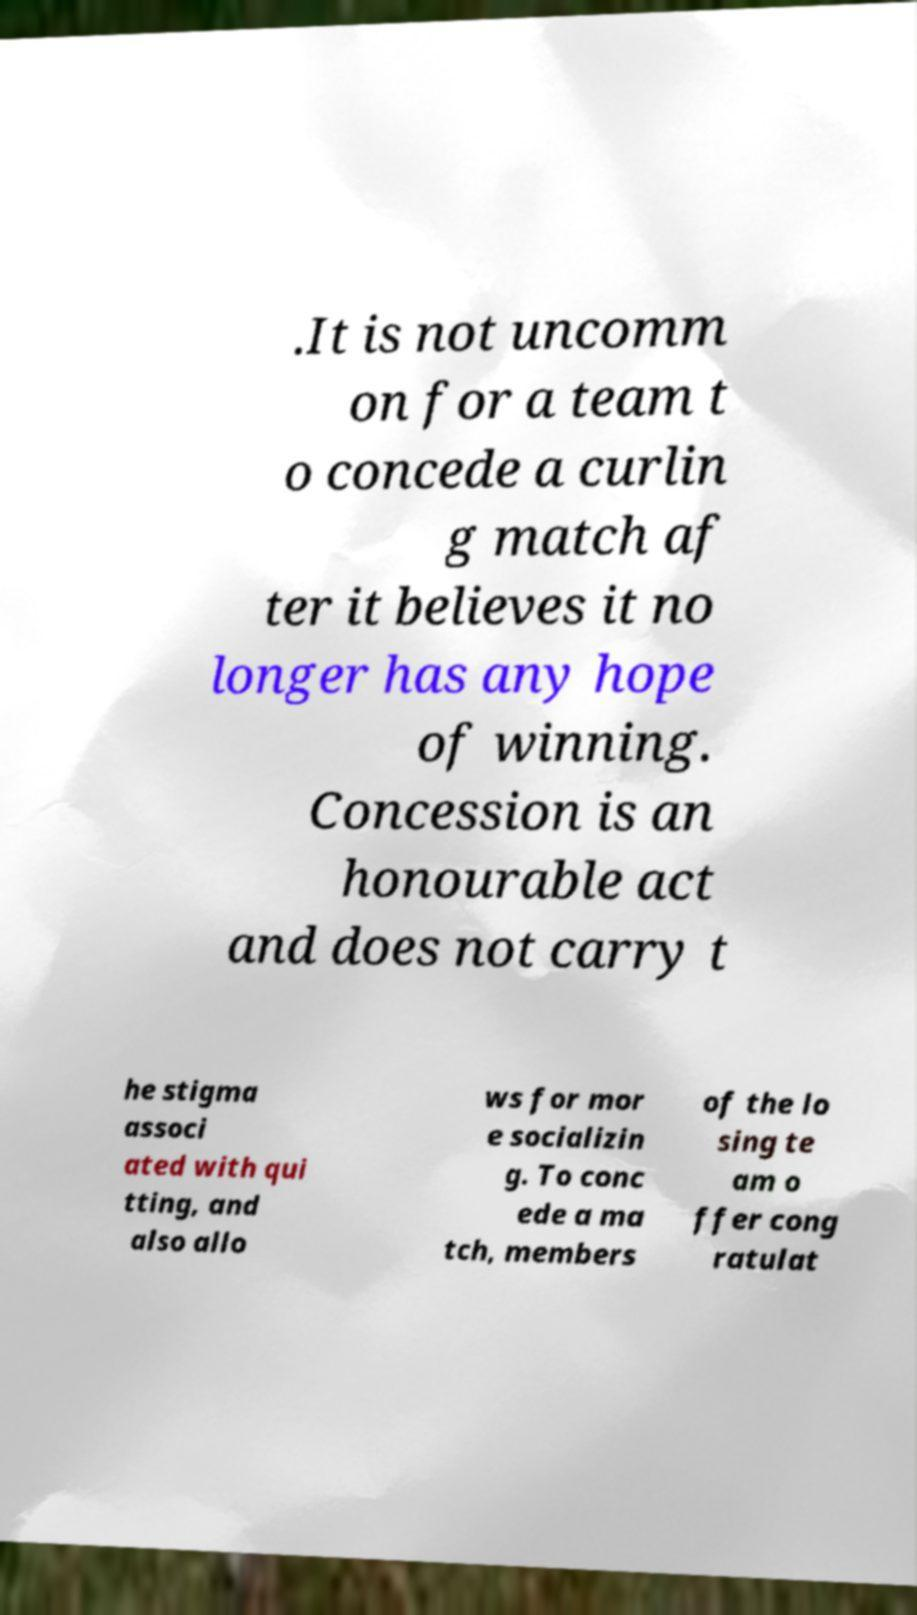Please identify and transcribe the text found in this image. .It is not uncomm on for a team t o concede a curlin g match af ter it believes it no longer has any hope of winning. Concession is an honourable act and does not carry t he stigma associ ated with qui tting, and also allo ws for mor e socializin g. To conc ede a ma tch, members of the lo sing te am o ffer cong ratulat 